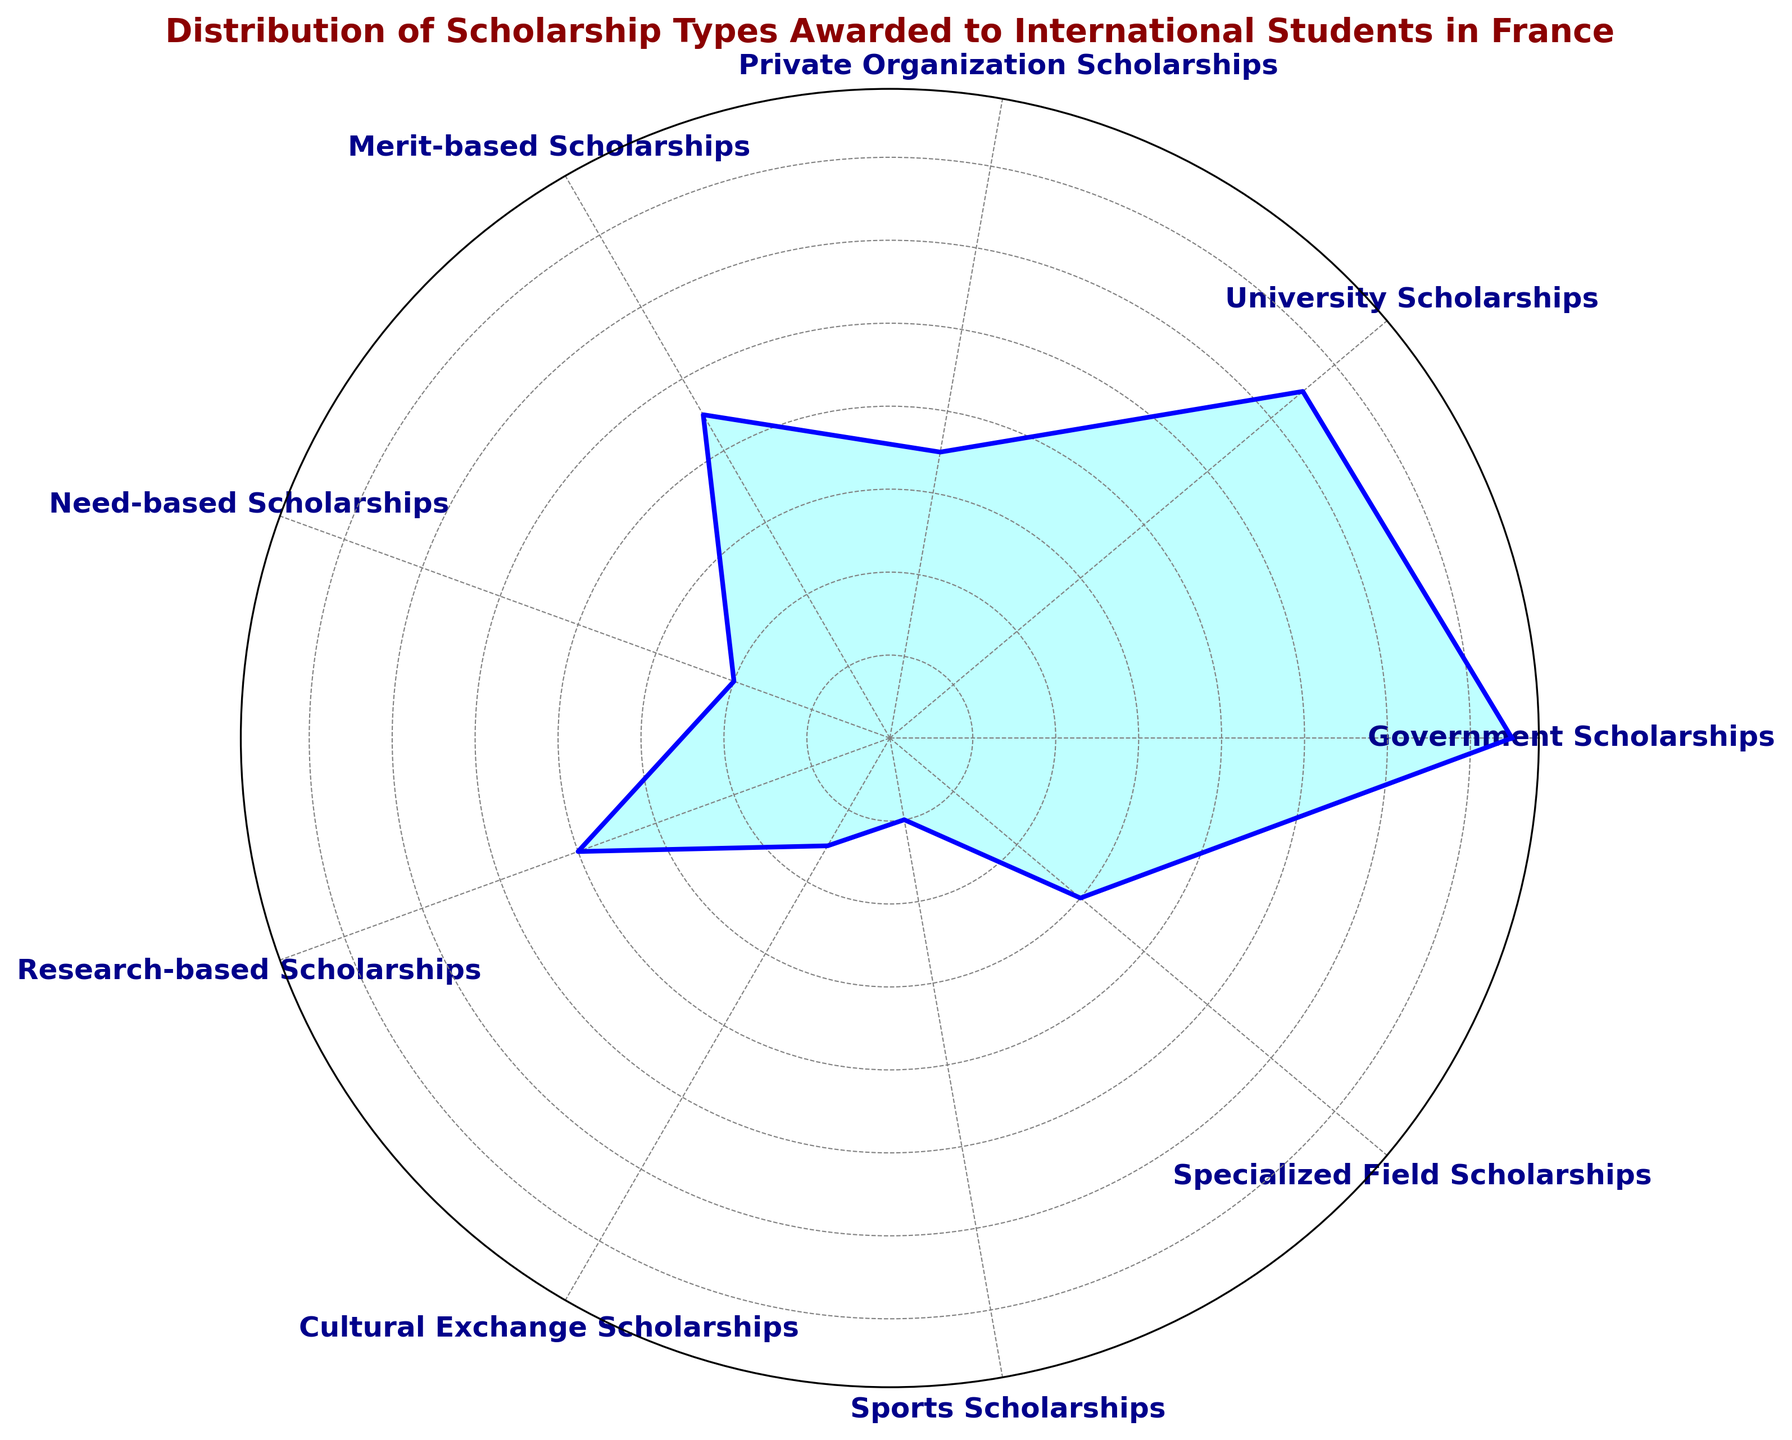Which scholarship type has the highest number of scholarships awarded? Looking at the lengths of the segments in the rose chart, the segment labeled "Government Scholarships" extends the furthest, indicating the highest number.
Answer: Government Scholarships Which two scholarship types have the least number of scholarships awarded, and what are the respective numbers? The shortest segments in the rose chart correspond to "Cultural Exchange Scholarships" and "Sports Scholarships." The numbers associated with these types are 300 and 200, respectively.
Answer: Cultural Exchange Scholarships (300) and Sports Scholarships (200) How many total scholarships are awarded in all categories? Summing all the given values: 1500 (Government) + 1300 (University) + 700 (Private) + 900 (Merit-based) + 400 (Need-based) + 800 (Research-based) + 300 (Cultural Exchange) + 200 (Sports) + 600 (Specialized Field) = 6700
Answer: 6700 What is the difference in the number of scholarships between University Scholarships and Merit-based Scholarships? Subtract the number of Merit-based Scholarships from University Scholarships: 1300 (University) - 900 (Merit-based) = 400
Answer: 400 Which scholarship type has more awards, Research-based Scholarships or Specialized Field Scholarships? By comparing the lengths of the corresponding segments, "Research-based Scholarships" have longer segments than "Specialized Field Scholarships," indicating more awards.
Answer: Research-based Scholarships If you combine the number of Government Scholarships and University Scholarships, does it exceed the total of Merit-based and Research-based Scholarships? Combine Government (1500) and University (1300): 1500 + 1300 = 2800. Then combine Merit-based (900) and Research-based (800): 900 + 800 = 1700. Since 2800 > 1700, it does exceed.
Answer: Yes Are Merit-based Scholarships more than twice the number of Need-based Scholarships? Compare twice the number of Need-based Scholarships to Merit-based Scholarships: 400 (Need-based) x 2 = 800. Since Merit-based (900) > 800, it is more.
Answer: Yes What is the average number of scholarships awarded across all types? Calculate the total number of scholarships (6700) and divide by the number of types (9): 6700 / 9 = 744.44.
Answer: 744.44 Between cultural exchange and specialized field scholarships, which type has a lower number and by how much? Compare the numbers: 300 (Cultural Exchange) and 600 (Specialized Field). The difference is 600 - 300 = 300
Answer: Cultural Exchange scholarships by 300 How do the numbers for Private Organization Scholarships and Sports Scholarships compare proportionally? Divide the number of Private Organization Scholarships by Sports Scholarships to find the ratio: 700 / 200 = 3.5, indicating that Private Organization Scholarships are 3.5 times more.
Answer: 3.5 times more 